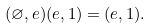Convert formula to latex. <formula><loc_0><loc_0><loc_500><loc_500>( \varnothing , e ) ( e , 1 ) = ( e , 1 ) .</formula> 